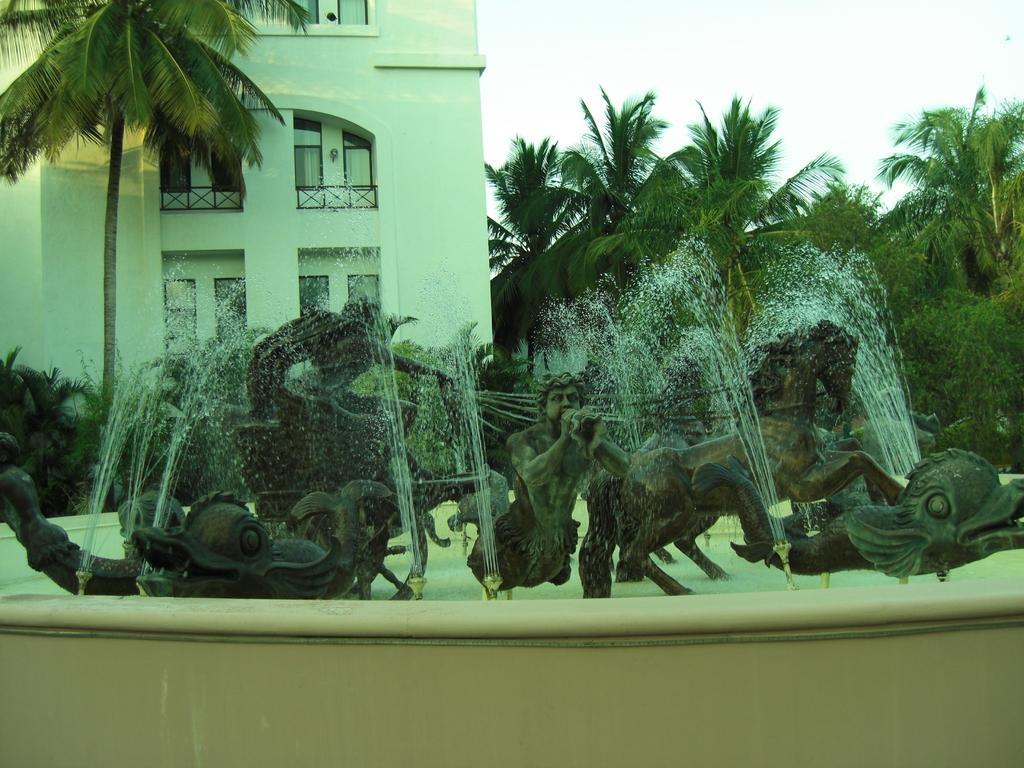What type of art can be seen in the image? There are sculptures in the image. What is the source of water visible in the image? There is a water fountain in the image. What type of vegetation is present in the image? There are trees in the image. What type of structure is visible in the image? There is a building in the image. What feature can be seen on the building in the image? The building has windows. What is visible in the background of the image? The sky is visible in the image. How many babies are playing with flowers in the image? There are no babies or flowers present in the image. What route is the person taking in the image? There is no person or route visible in the image. 